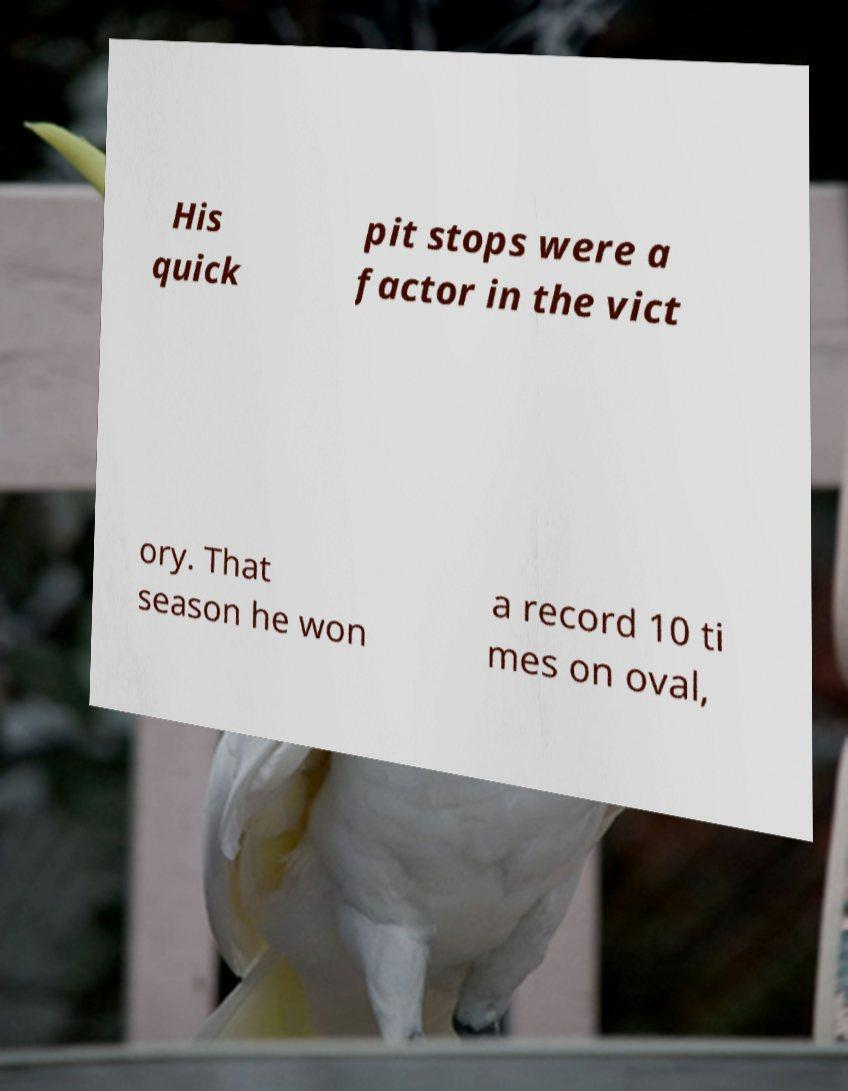Please identify and transcribe the text found in this image. His quick pit stops were a factor in the vict ory. That season he won a record 10 ti mes on oval, 